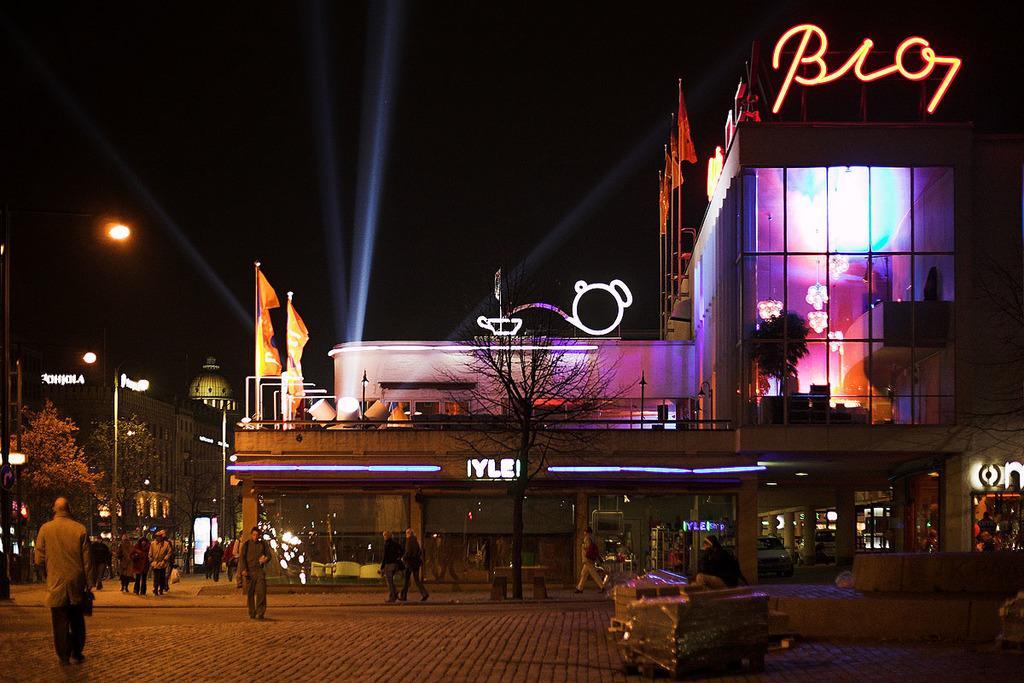Could you give a brief overview of what you see in this image? In this image few persons are walking on the pavement having few trees. Right side there is a building having few flags. Inside the building few lights are hanged from the roof. Left side there are few street lights. Behind there are few trees. Background there are few buildings. Top of the image there is sky. 